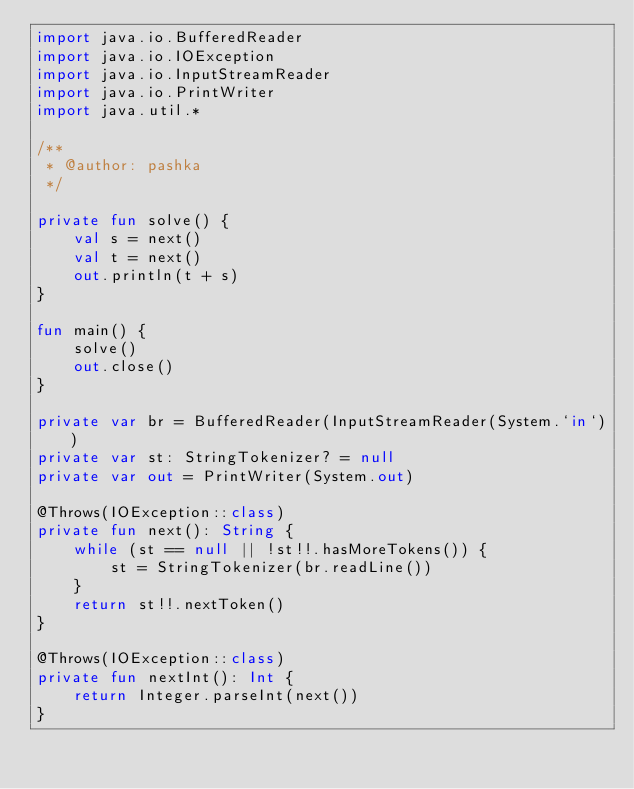<code> <loc_0><loc_0><loc_500><loc_500><_Kotlin_>import java.io.BufferedReader
import java.io.IOException
import java.io.InputStreamReader
import java.io.PrintWriter
import java.util.*

/**
 * @author: pashka
 */

private fun solve() {
    val s = next()
    val t = next()
    out.println(t + s)
}

fun main() {
    solve()
    out.close()
}

private var br = BufferedReader(InputStreamReader(System.`in`))
private var st: StringTokenizer? = null
private var out = PrintWriter(System.out)

@Throws(IOException::class)
private fun next(): String {
    while (st == null || !st!!.hasMoreTokens()) {
        st = StringTokenizer(br.readLine())
    }
    return st!!.nextToken()
}

@Throws(IOException::class)
private fun nextInt(): Int {
    return Integer.parseInt(next())
}
</code> 